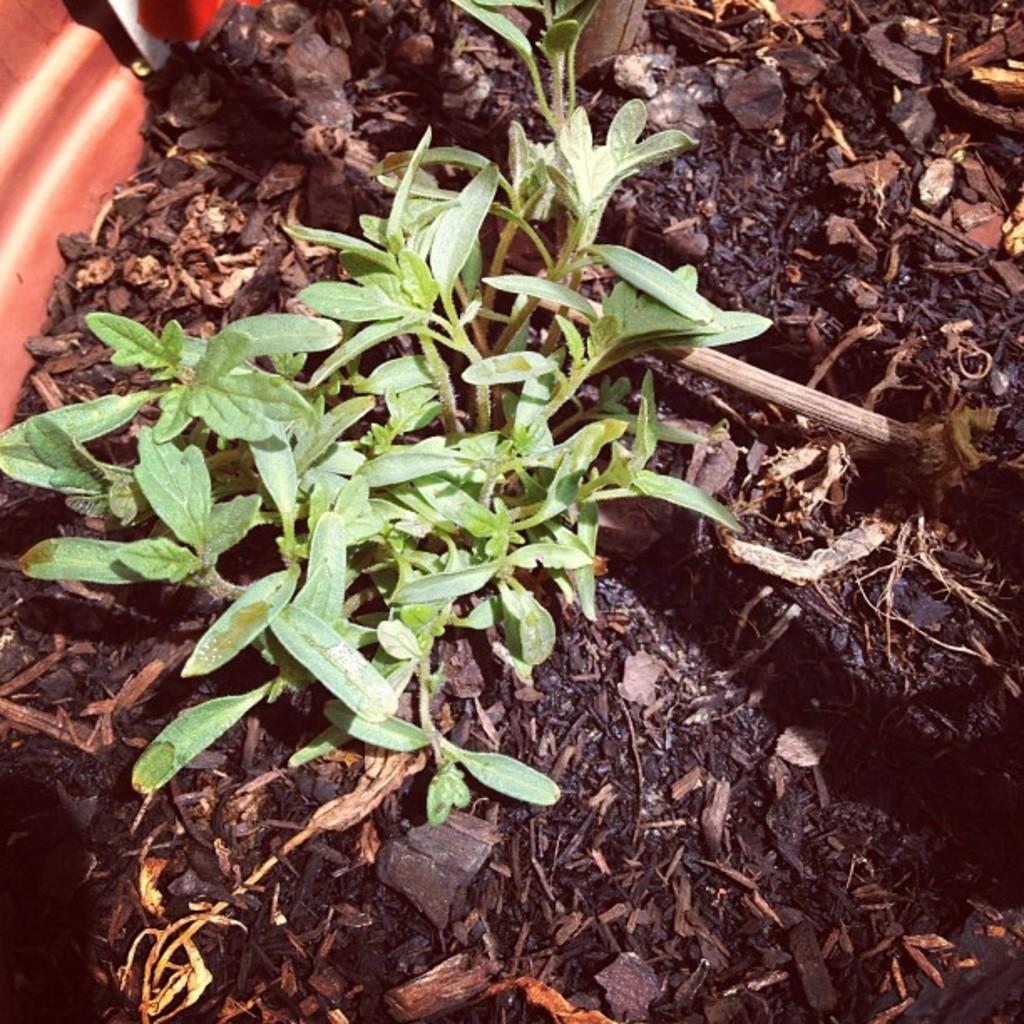Could you give a brief overview of what you see in this image? In this picture we can see small green plants. There are a few dry leaves on the path. 